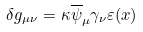Convert formula to latex. <formula><loc_0><loc_0><loc_500><loc_500>\delta g _ { \mu \nu } = \kappa \overline { \psi } _ { \mu } \gamma _ { \nu } \varepsilon ( x )</formula> 